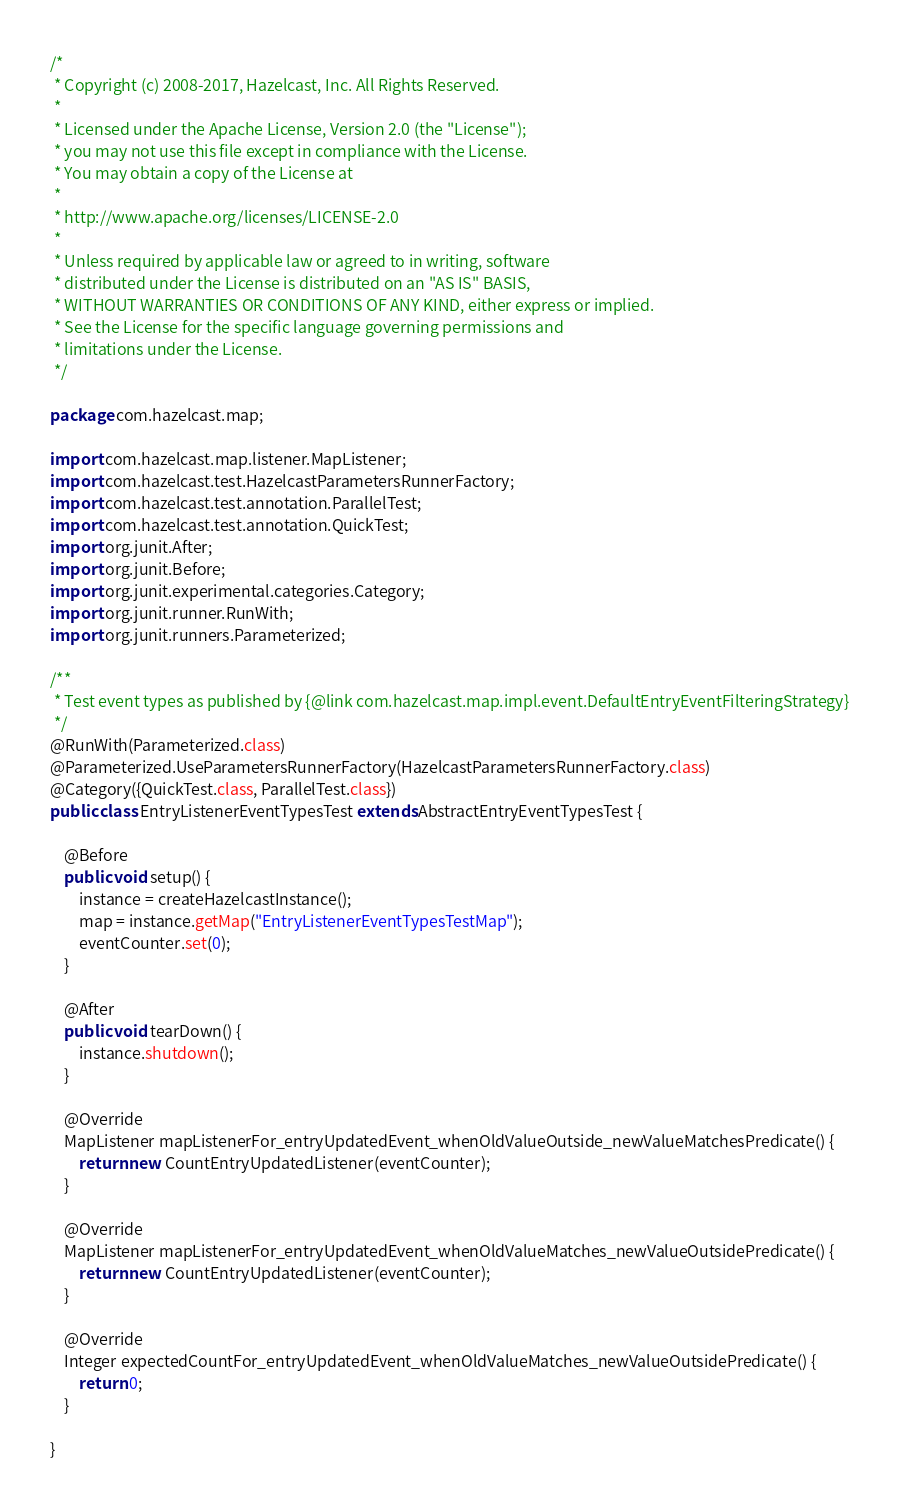Convert code to text. <code><loc_0><loc_0><loc_500><loc_500><_Java_>/*
 * Copyright (c) 2008-2017, Hazelcast, Inc. All Rights Reserved.
 *
 * Licensed under the Apache License, Version 2.0 (the "License");
 * you may not use this file except in compliance with the License.
 * You may obtain a copy of the License at
 *
 * http://www.apache.org/licenses/LICENSE-2.0
 *
 * Unless required by applicable law or agreed to in writing, software
 * distributed under the License is distributed on an "AS IS" BASIS,
 * WITHOUT WARRANTIES OR CONDITIONS OF ANY KIND, either express or implied.
 * See the License for the specific language governing permissions and
 * limitations under the License.
 */

package com.hazelcast.map;

import com.hazelcast.map.listener.MapListener;
import com.hazelcast.test.HazelcastParametersRunnerFactory;
import com.hazelcast.test.annotation.ParallelTest;
import com.hazelcast.test.annotation.QuickTest;
import org.junit.After;
import org.junit.Before;
import org.junit.experimental.categories.Category;
import org.junit.runner.RunWith;
import org.junit.runners.Parameterized;

/**
 * Test event types as published by {@link com.hazelcast.map.impl.event.DefaultEntryEventFilteringStrategy}
 */
@RunWith(Parameterized.class)
@Parameterized.UseParametersRunnerFactory(HazelcastParametersRunnerFactory.class)
@Category({QuickTest.class, ParallelTest.class})
public class EntryListenerEventTypesTest extends AbstractEntryEventTypesTest {

    @Before
    public void setup() {
        instance = createHazelcastInstance();
        map = instance.getMap("EntryListenerEventTypesTestMap");
        eventCounter.set(0);
    }

    @After
    public void tearDown() {
        instance.shutdown();
    }

    @Override
    MapListener mapListenerFor_entryUpdatedEvent_whenOldValueOutside_newValueMatchesPredicate() {
        return new CountEntryUpdatedListener(eventCounter);
    }

    @Override
    MapListener mapListenerFor_entryUpdatedEvent_whenOldValueMatches_newValueOutsidePredicate() {
        return new CountEntryUpdatedListener(eventCounter);
    }

    @Override
    Integer expectedCountFor_entryUpdatedEvent_whenOldValueMatches_newValueOutsidePredicate() {
        return 0;
    }

}
</code> 